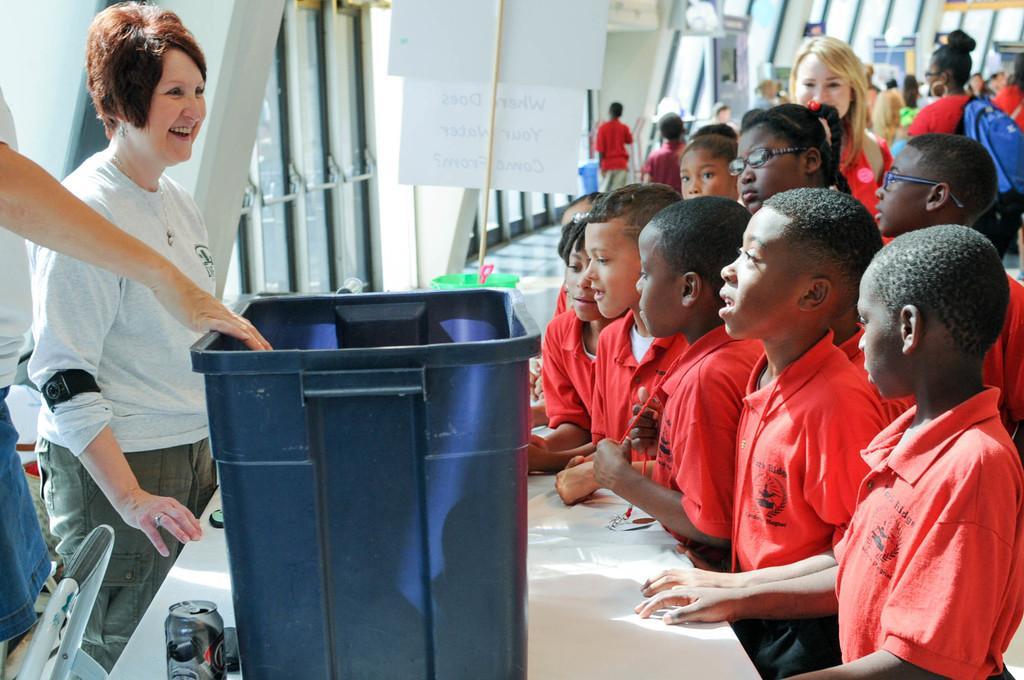In one or two sentences, can you explain what this image depicts? In this image there are many children standing. In front of them there is a table. On the table there is a drink can. Beside it there is a basket. To the left there is a woman standing near to the table. Behind them there is a wall. Near to the wall there are boards. 